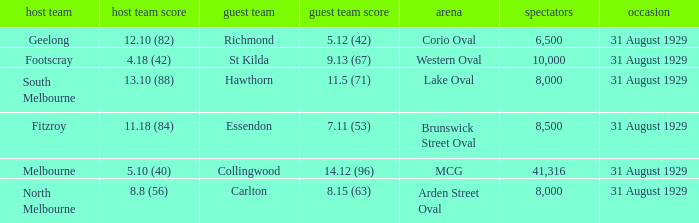What is the score of the away team when the crowd was larger than 8,000? 9.13 (67), 7.11 (53), 14.12 (96). 